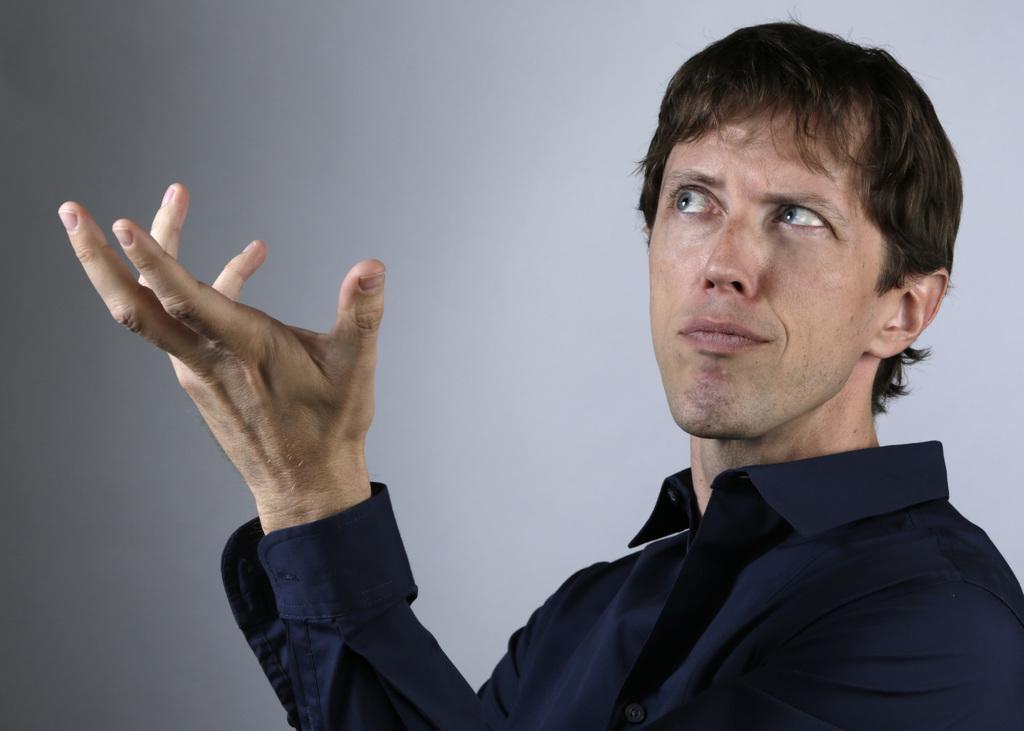In one or two sentences, can you explain what this image depicts? In the foreground of the image there is a person wearing blue color shirt. In the background of the image there is wall. 